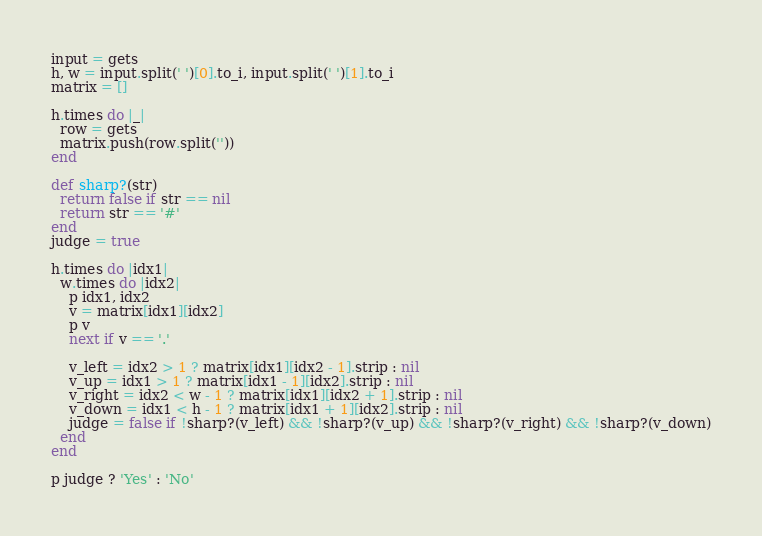Convert code to text. <code><loc_0><loc_0><loc_500><loc_500><_Ruby_>input = gets
h, w = input.split(' ')[0].to_i, input.split(' ')[1].to_i
matrix = []

h.times do |_|
  row = gets
  matrix.push(row.split(''))
end

def sharp?(str)
  return false if str == nil
  return str == '#'
end
judge = true

h.times do |idx1|
  w.times do |idx2|
    p idx1, idx2
    v = matrix[idx1][idx2]
    p v
    next if v == '.'

    v_left = idx2 > 1 ? matrix[idx1][idx2 - 1].strip : nil
    v_up = idx1 > 1 ? matrix[idx1 - 1][idx2].strip : nil
    v_right = idx2 < w - 1 ? matrix[idx1][idx2 + 1].strip : nil
    v_down = idx1 < h - 1 ? matrix[idx1 + 1][idx2].strip : nil
    judge = false if !sharp?(v_left) && !sharp?(v_up) && !sharp?(v_right) && !sharp?(v_down)
  end
end

p judge ? 'Yes' : 'No'
</code> 